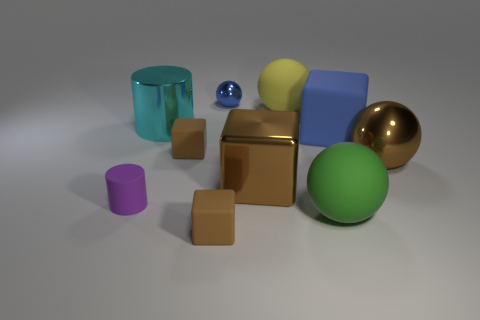Subtract all brown spheres. How many brown blocks are left? 3 Subtract all blue blocks. How many blocks are left? 3 Subtract all big matte cubes. How many cubes are left? 3 Subtract all purple spheres. Subtract all brown cubes. How many spheres are left? 4 Subtract all spheres. How many objects are left? 6 Add 3 metal things. How many metal things exist? 7 Subtract 0 red cylinders. How many objects are left? 10 Subtract all big red cylinders. Subtract all metal cylinders. How many objects are left? 9 Add 4 small metallic spheres. How many small metallic spheres are left? 5 